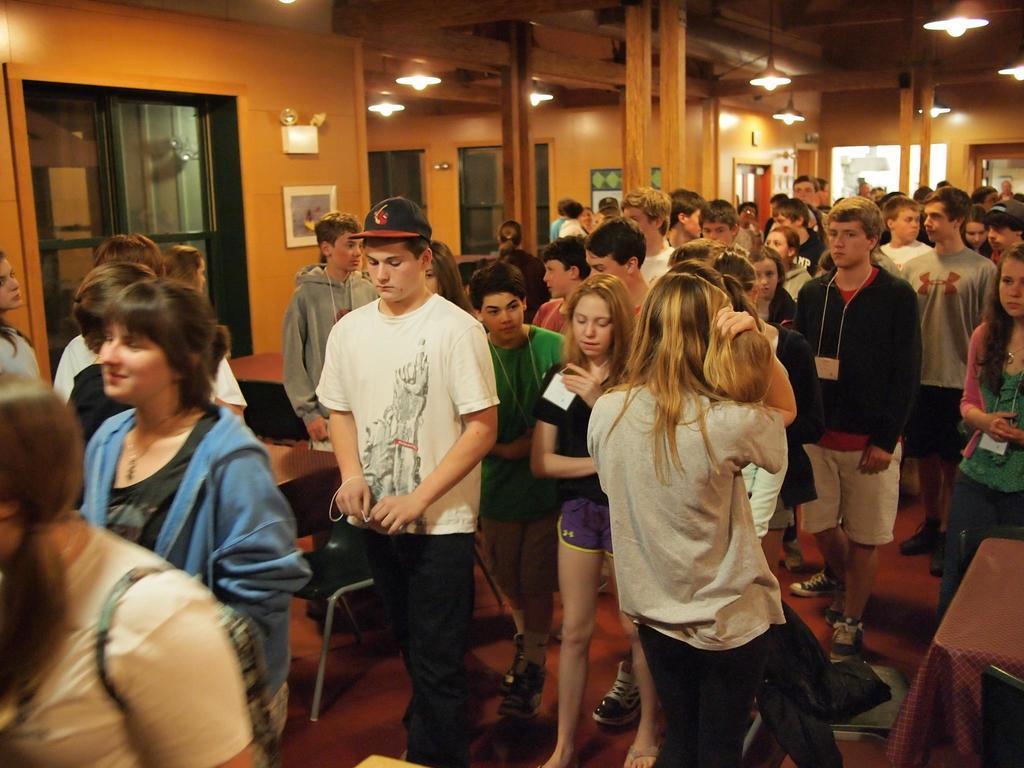In one or two sentences, can you explain what this image depicts? This is the picture taken in a room, there are group of people standing on the floor. Behind the people there is a glass window, wall with photo and pillar and there are ceiling lights on the top. 